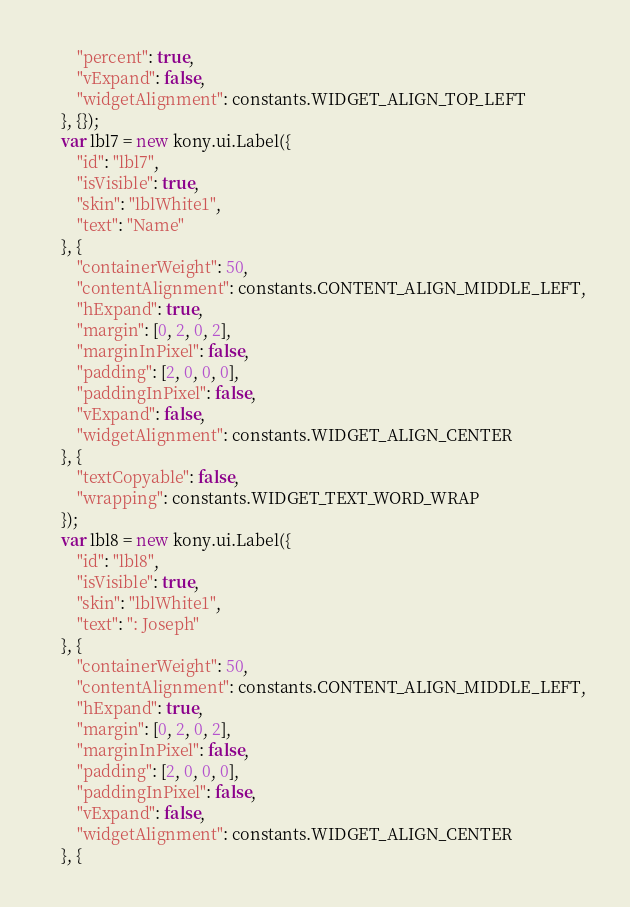<code> <loc_0><loc_0><loc_500><loc_500><_JavaScript_>        "percent": true,
        "vExpand": false,
        "widgetAlignment": constants.WIDGET_ALIGN_TOP_LEFT
    }, {});
    var lbl7 = new kony.ui.Label({
        "id": "lbl7",
        "isVisible": true,
        "skin": "lblWhite1",
        "text": "Name"
    }, {
        "containerWeight": 50,
        "contentAlignment": constants.CONTENT_ALIGN_MIDDLE_LEFT,
        "hExpand": true,
        "margin": [0, 2, 0, 2],
        "marginInPixel": false,
        "padding": [2, 0, 0, 0],
        "paddingInPixel": false,
        "vExpand": false,
        "widgetAlignment": constants.WIDGET_ALIGN_CENTER
    }, {
        "textCopyable": false,
        "wrapping": constants.WIDGET_TEXT_WORD_WRAP
    });
    var lbl8 = new kony.ui.Label({
        "id": "lbl8",
        "isVisible": true,
        "skin": "lblWhite1",
        "text": ": Joseph"
    }, {
        "containerWeight": 50,
        "contentAlignment": constants.CONTENT_ALIGN_MIDDLE_LEFT,
        "hExpand": true,
        "margin": [0, 2, 0, 2],
        "marginInPixel": false,
        "padding": [2, 0, 0, 0],
        "paddingInPixel": false,
        "vExpand": false,
        "widgetAlignment": constants.WIDGET_ALIGN_CENTER
    }, {</code> 